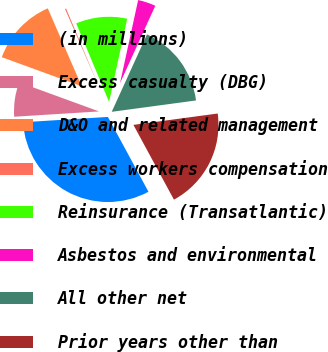Convert chart. <chart><loc_0><loc_0><loc_500><loc_500><pie_chart><fcel>(in millions)<fcel>Excess casualty (DBG)<fcel>D&O and related management<fcel>Excess workers compensation<fcel>Reinsurance (Transatlantic)<fcel>Asbestos and environmental<fcel>All other net<fcel>Prior years other than<nl><fcel>31.91%<fcel>6.56%<fcel>12.9%<fcel>0.22%<fcel>9.73%<fcel>3.39%<fcel>16.06%<fcel>19.23%<nl></chart> 